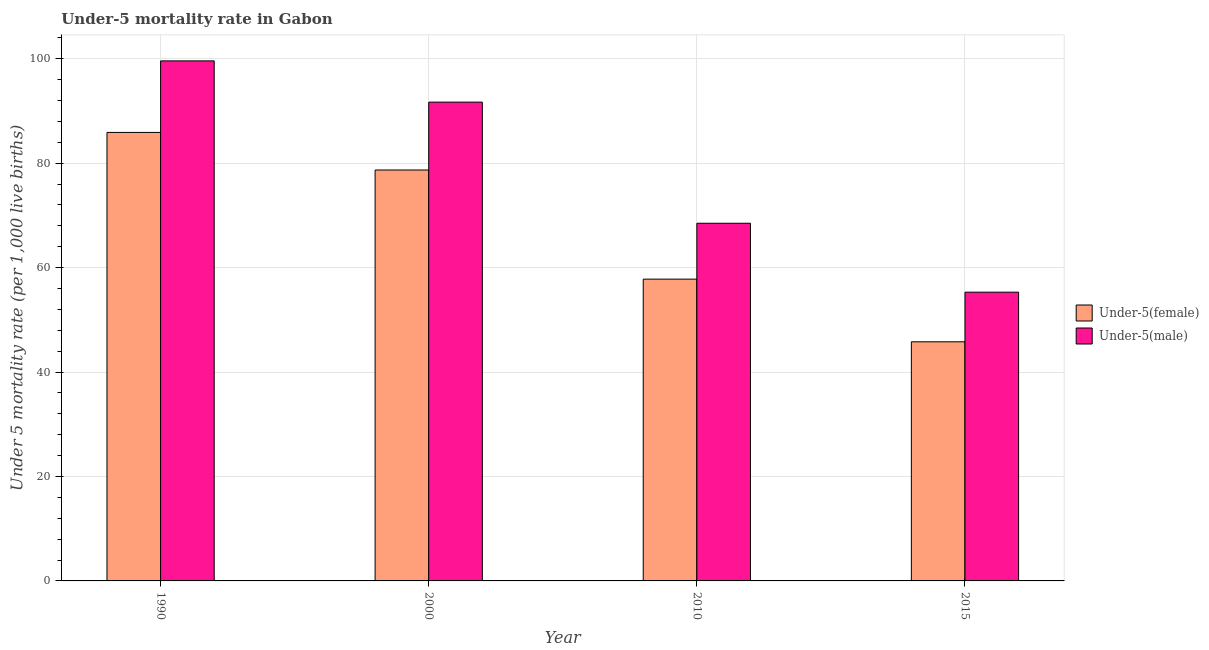How many different coloured bars are there?
Provide a succinct answer. 2. How many groups of bars are there?
Ensure brevity in your answer.  4. Are the number of bars on each tick of the X-axis equal?
Provide a succinct answer. Yes. How many bars are there on the 1st tick from the left?
Provide a succinct answer. 2. How many bars are there on the 3rd tick from the right?
Your response must be concise. 2. What is the label of the 1st group of bars from the left?
Ensure brevity in your answer.  1990. In how many cases, is the number of bars for a given year not equal to the number of legend labels?
Give a very brief answer. 0. What is the under-5 female mortality rate in 2010?
Give a very brief answer. 57.8. Across all years, what is the maximum under-5 male mortality rate?
Ensure brevity in your answer.  99.6. Across all years, what is the minimum under-5 male mortality rate?
Keep it short and to the point. 55.3. In which year was the under-5 male mortality rate maximum?
Make the answer very short. 1990. In which year was the under-5 male mortality rate minimum?
Ensure brevity in your answer.  2015. What is the total under-5 female mortality rate in the graph?
Provide a succinct answer. 268.2. What is the difference between the under-5 male mortality rate in 2000 and that in 2010?
Your answer should be compact. 23.2. What is the difference between the under-5 male mortality rate in 2015 and the under-5 female mortality rate in 1990?
Provide a short and direct response. -44.3. What is the average under-5 male mortality rate per year?
Make the answer very short. 78.78. In how many years, is the under-5 male mortality rate greater than 16?
Provide a succinct answer. 4. What is the ratio of the under-5 male mortality rate in 2010 to that in 2015?
Give a very brief answer. 1.24. Is the difference between the under-5 male mortality rate in 1990 and 2000 greater than the difference between the under-5 female mortality rate in 1990 and 2000?
Give a very brief answer. No. What is the difference between the highest and the second highest under-5 female mortality rate?
Keep it short and to the point. 7.2. What is the difference between the highest and the lowest under-5 male mortality rate?
Make the answer very short. 44.3. What does the 1st bar from the left in 1990 represents?
Give a very brief answer. Under-5(female). What does the 1st bar from the right in 2010 represents?
Provide a succinct answer. Under-5(male). How many bars are there?
Your response must be concise. 8. How many years are there in the graph?
Provide a short and direct response. 4. What is the difference between two consecutive major ticks on the Y-axis?
Your response must be concise. 20. Are the values on the major ticks of Y-axis written in scientific E-notation?
Give a very brief answer. No. Does the graph contain any zero values?
Make the answer very short. No. What is the title of the graph?
Make the answer very short. Under-5 mortality rate in Gabon. What is the label or title of the X-axis?
Offer a terse response. Year. What is the label or title of the Y-axis?
Your answer should be compact. Under 5 mortality rate (per 1,0 live births). What is the Under 5 mortality rate (per 1,000 live births) in Under-5(female) in 1990?
Provide a succinct answer. 85.9. What is the Under 5 mortality rate (per 1,000 live births) of Under-5(male) in 1990?
Your answer should be compact. 99.6. What is the Under 5 mortality rate (per 1,000 live births) of Under-5(female) in 2000?
Your answer should be very brief. 78.7. What is the Under 5 mortality rate (per 1,000 live births) in Under-5(male) in 2000?
Give a very brief answer. 91.7. What is the Under 5 mortality rate (per 1,000 live births) in Under-5(female) in 2010?
Give a very brief answer. 57.8. What is the Under 5 mortality rate (per 1,000 live births) of Under-5(male) in 2010?
Your answer should be very brief. 68.5. What is the Under 5 mortality rate (per 1,000 live births) of Under-5(female) in 2015?
Make the answer very short. 45.8. What is the Under 5 mortality rate (per 1,000 live births) of Under-5(male) in 2015?
Offer a very short reply. 55.3. Across all years, what is the maximum Under 5 mortality rate (per 1,000 live births) in Under-5(female)?
Your answer should be compact. 85.9. Across all years, what is the maximum Under 5 mortality rate (per 1,000 live births) of Under-5(male)?
Keep it short and to the point. 99.6. Across all years, what is the minimum Under 5 mortality rate (per 1,000 live births) in Under-5(female)?
Ensure brevity in your answer.  45.8. Across all years, what is the minimum Under 5 mortality rate (per 1,000 live births) of Under-5(male)?
Offer a terse response. 55.3. What is the total Under 5 mortality rate (per 1,000 live births) in Under-5(female) in the graph?
Your answer should be compact. 268.2. What is the total Under 5 mortality rate (per 1,000 live births) of Under-5(male) in the graph?
Offer a terse response. 315.1. What is the difference between the Under 5 mortality rate (per 1,000 live births) in Under-5(female) in 1990 and that in 2010?
Provide a succinct answer. 28.1. What is the difference between the Under 5 mortality rate (per 1,000 live births) of Under-5(male) in 1990 and that in 2010?
Offer a terse response. 31.1. What is the difference between the Under 5 mortality rate (per 1,000 live births) in Under-5(female) in 1990 and that in 2015?
Give a very brief answer. 40.1. What is the difference between the Under 5 mortality rate (per 1,000 live births) in Under-5(male) in 1990 and that in 2015?
Provide a succinct answer. 44.3. What is the difference between the Under 5 mortality rate (per 1,000 live births) in Under-5(female) in 2000 and that in 2010?
Your answer should be very brief. 20.9. What is the difference between the Under 5 mortality rate (per 1,000 live births) of Under-5(male) in 2000 and that in 2010?
Ensure brevity in your answer.  23.2. What is the difference between the Under 5 mortality rate (per 1,000 live births) of Under-5(female) in 2000 and that in 2015?
Offer a terse response. 32.9. What is the difference between the Under 5 mortality rate (per 1,000 live births) in Under-5(male) in 2000 and that in 2015?
Give a very brief answer. 36.4. What is the difference between the Under 5 mortality rate (per 1,000 live births) in Under-5(female) in 1990 and the Under 5 mortality rate (per 1,000 live births) in Under-5(male) in 2000?
Your response must be concise. -5.8. What is the difference between the Under 5 mortality rate (per 1,000 live births) in Under-5(female) in 1990 and the Under 5 mortality rate (per 1,000 live births) in Under-5(male) in 2015?
Offer a terse response. 30.6. What is the difference between the Under 5 mortality rate (per 1,000 live births) in Under-5(female) in 2000 and the Under 5 mortality rate (per 1,000 live births) in Under-5(male) in 2010?
Offer a very short reply. 10.2. What is the difference between the Under 5 mortality rate (per 1,000 live births) of Under-5(female) in 2000 and the Under 5 mortality rate (per 1,000 live births) of Under-5(male) in 2015?
Offer a terse response. 23.4. What is the average Under 5 mortality rate (per 1,000 live births) in Under-5(female) per year?
Keep it short and to the point. 67.05. What is the average Under 5 mortality rate (per 1,000 live births) of Under-5(male) per year?
Provide a short and direct response. 78.78. In the year 1990, what is the difference between the Under 5 mortality rate (per 1,000 live births) in Under-5(female) and Under 5 mortality rate (per 1,000 live births) in Under-5(male)?
Offer a very short reply. -13.7. In the year 2000, what is the difference between the Under 5 mortality rate (per 1,000 live births) in Under-5(female) and Under 5 mortality rate (per 1,000 live births) in Under-5(male)?
Your response must be concise. -13. In the year 2015, what is the difference between the Under 5 mortality rate (per 1,000 live births) of Under-5(female) and Under 5 mortality rate (per 1,000 live births) of Under-5(male)?
Make the answer very short. -9.5. What is the ratio of the Under 5 mortality rate (per 1,000 live births) in Under-5(female) in 1990 to that in 2000?
Offer a very short reply. 1.09. What is the ratio of the Under 5 mortality rate (per 1,000 live births) in Under-5(male) in 1990 to that in 2000?
Offer a very short reply. 1.09. What is the ratio of the Under 5 mortality rate (per 1,000 live births) in Under-5(female) in 1990 to that in 2010?
Offer a very short reply. 1.49. What is the ratio of the Under 5 mortality rate (per 1,000 live births) in Under-5(male) in 1990 to that in 2010?
Your answer should be very brief. 1.45. What is the ratio of the Under 5 mortality rate (per 1,000 live births) in Under-5(female) in 1990 to that in 2015?
Your response must be concise. 1.88. What is the ratio of the Under 5 mortality rate (per 1,000 live births) in Under-5(male) in 1990 to that in 2015?
Offer a terse response. 1.8. What is the ratio of the Under 5 mortality rate (per 1,000 live births) in Under-5(female) in 2000 to that in 2010?
Keep it short and to the point. 1.36. What is the ratio of the Under 5 mortality rate (per 1,000 live births) of Under-5(male) in 2000 to that in 2010?
Provide a short and direct response. 1.34. What is the ratio of the Under 5 mortality rate (per 1,000 live births) in Under-5(female) in 2000 to that in 2015?
Make the answer very short. 1.72. What is the ratio of the Under 5 mortality rate (per 1,000 live births) of Under-5(male) in 2000 to that in 2015?
Give a very brief answer. 1.66. What is the ratio of the Under 5 mortality rate (per 1,000 live births) in Under-5(female) in 2010 to that in 2015?
Provide a short and direct response. 1.26. What is the ratio of the Under 5 mortality rate (per 1,000 live births) in Under-5(male) in 2010 to that in 2015?
Your answer should be compact. 1.24. What is the difference between the highest and the second highest Under 5 mortality rate (per 1,000 live births) in Under-5(female)?
Offer a very short reply. 7.2. What is the difference between the highest and the lowest Under 5 mortality rate (per 1,000 live births) of Under-5(female)?
Your answer should be compact. 40.1. What is the difference between the highest and the lowest Under 5 mortality rate (per 1,000 live births) in Under-5(male)?
Provide a short and direct response. 44.3. 